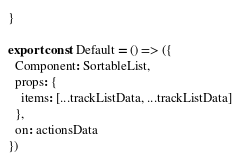Convert code to text. <code><loc_0><loc_0><loc_500><loc_500><_JavaScript_>}

export const Default = () => ({
  Component: SortableList,
  props: {
    items: [...trackListData, ...trackListData]
  },
  on: actionsData
})
</code> 